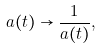Convert formula to latex. <formula><loc_0><loc_0><loc_500><loc_500>a ( t ) \to \frac { 1 } { a ( t ) } ,</formula> 